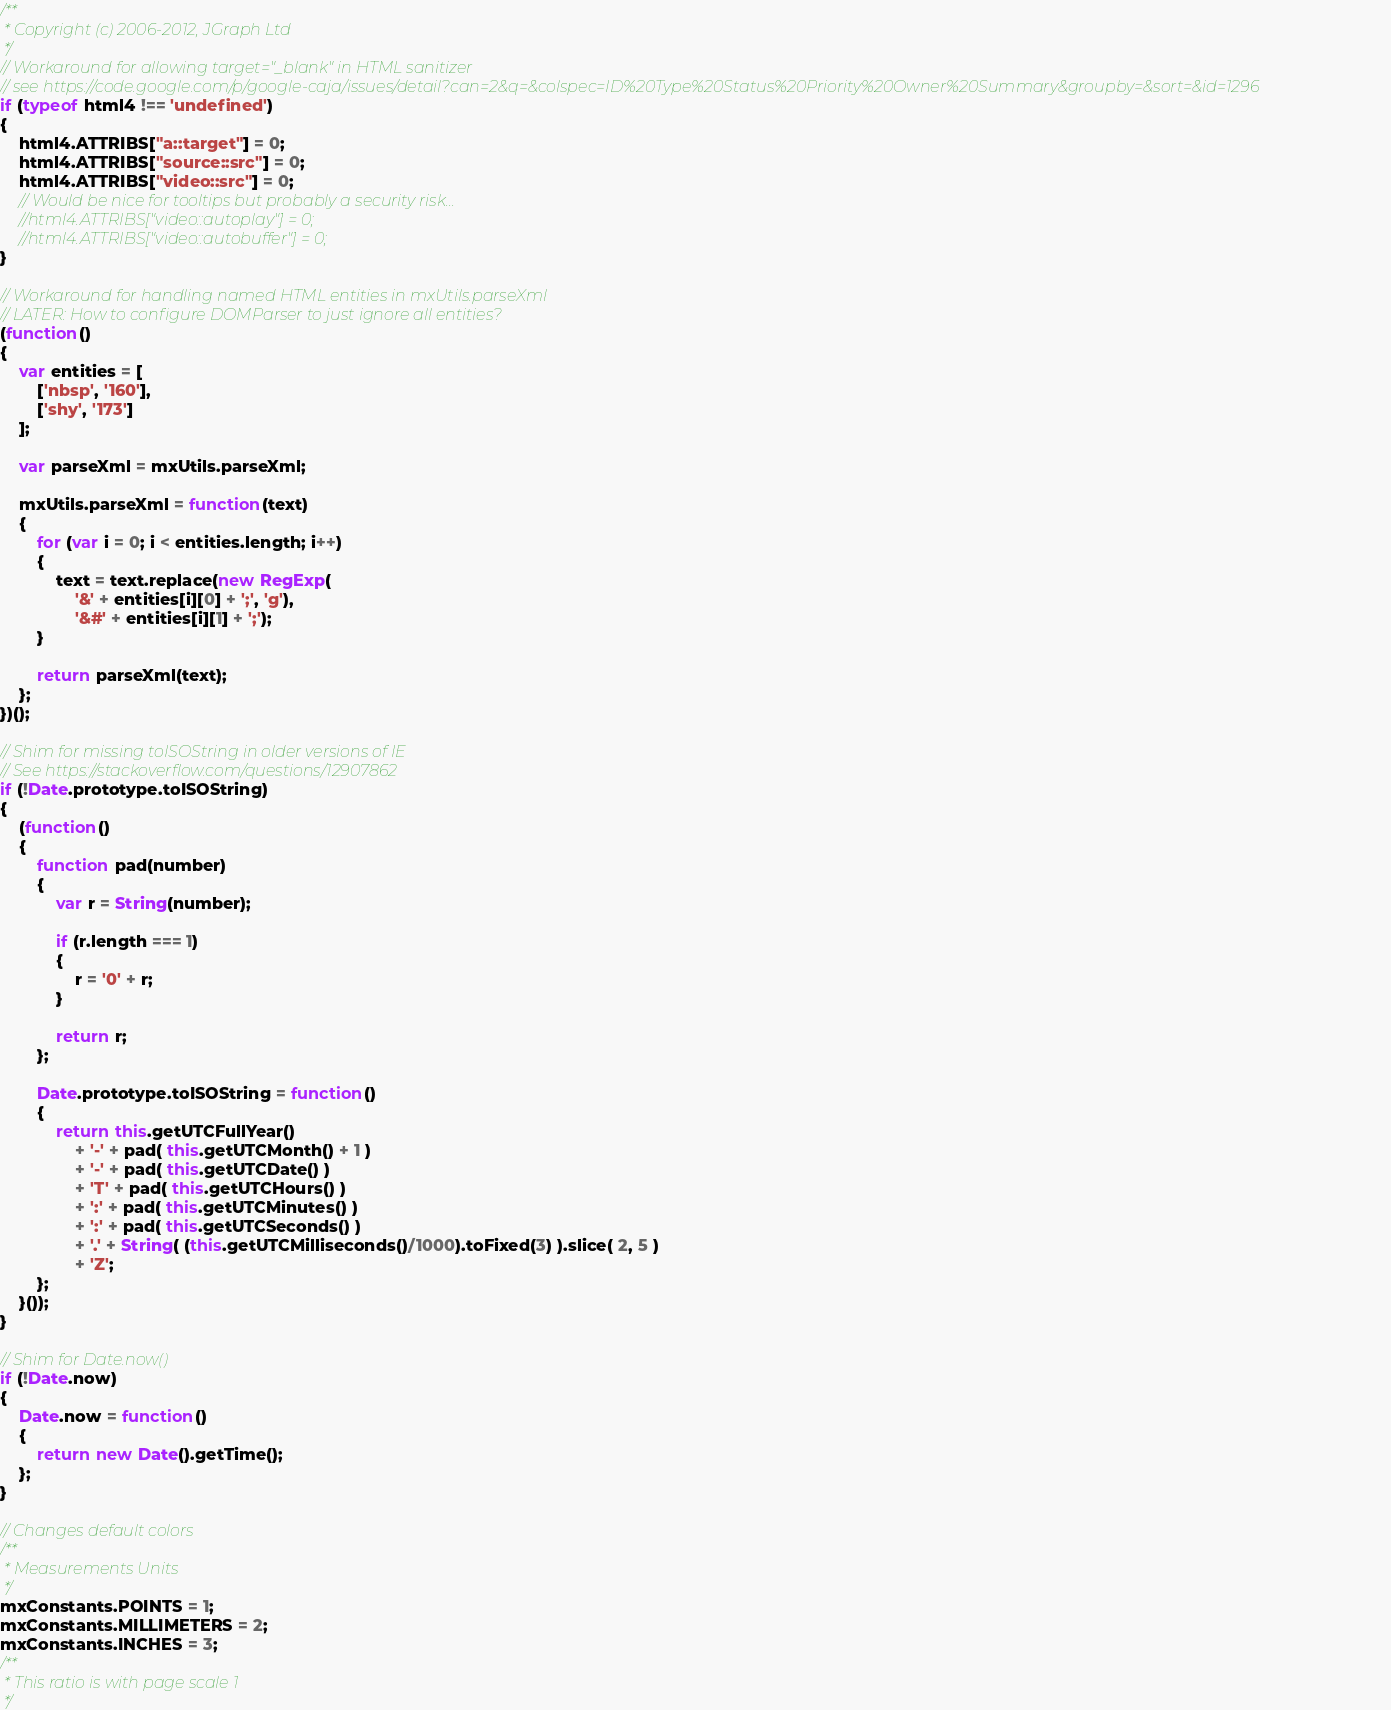<code> <loc_0><loc_0><loc_500><loc_500><_JavaScript_>/**
 * Copyright (c) 2006-2012, JGraph Ltd
 */
// Workaround for allowing target="_blank" in HTML sanitizer
// see https://code.google.com/p/google-caja/issues/detail?can=2&q=&colspec=ID%20Type%20Status%20Priority%20Owner%20Summary&groupby=&sort=&id=1296
if (typeof html4 !== 'undefined')
{
	html4.ATTRIBS["a::target"] = 0;
	html4.ATTRIBS["source::src"] = 0;
	html4.ATTRIBS["video::src"] = 0;
	// Would be nice for tooltips but probably a security risk...
	//html4.ATTRIBS["video::autoplay"] = 0;
	//html4.ATTRIBS["video::autobuffer"] = 0;
}

// Workaround for handling named HTML entities in mxUtils.parseXml
// LATER: How to configure DOMParser to just ignore all entities?
(function()
{
	var entities = [
		['nbsp', '160'],
		['shy', '173']
    ];

	var parseXml = mxUtils.parseXml;
	
	mxUtils.parseXml = function(text)
	{
		for (var i = 0; i < entities.length; i++)
	    {
	        text = text.replace(new RegExp(
	        	'&' + entities[i][0] + ';', 'g'),
		        '&#' + entities[i][1] + ';');
	    }

		return parseXml(text);
	};
})();

// Shim for missing toISOString in older versions of IE
// See https://stackoverflow.com/questions/12907862
if (!Date.prototype.toISOString)
{         
    (function()
    {         
        function pad(number)
        {
            var r = String(number);
            
            if (r.length === 1) 
            {
                r = '0' + r;
            }
            
            return r;
        };
        
        Date.prototype.toISOString = function()
        {
            return this.getUTCFullYear()
                + '-' + pad( this.getUTCMonth() + 1 )
                + '-' + pad( this.getUTCDate() )
                + 'T' + pad( this.getUTCHours() )
                + ':' + pad( this.getUTCMinutes() )
                + ':' + pad( this.getUTCSeconds() )
                + '.' + String( (this.getUTCMilliseconds()/1000).toFixed(3) ).slice( 2, 5 )
                + 'Z';
        };       
    }());
}

// Shim for Date.now()
if (!Date.now)
{
	Date.now = function()
	{
		return new Date().getTime();
	};
}

// Changes default colors
/**
 * Measurements Units
 */
mxConstants.POINTS = 1;
mxConstants.MILLIMETERS = 2;
mxConstants.INCHES = 3;
/**
 * This ratio is with page scale 1
 */</code> 